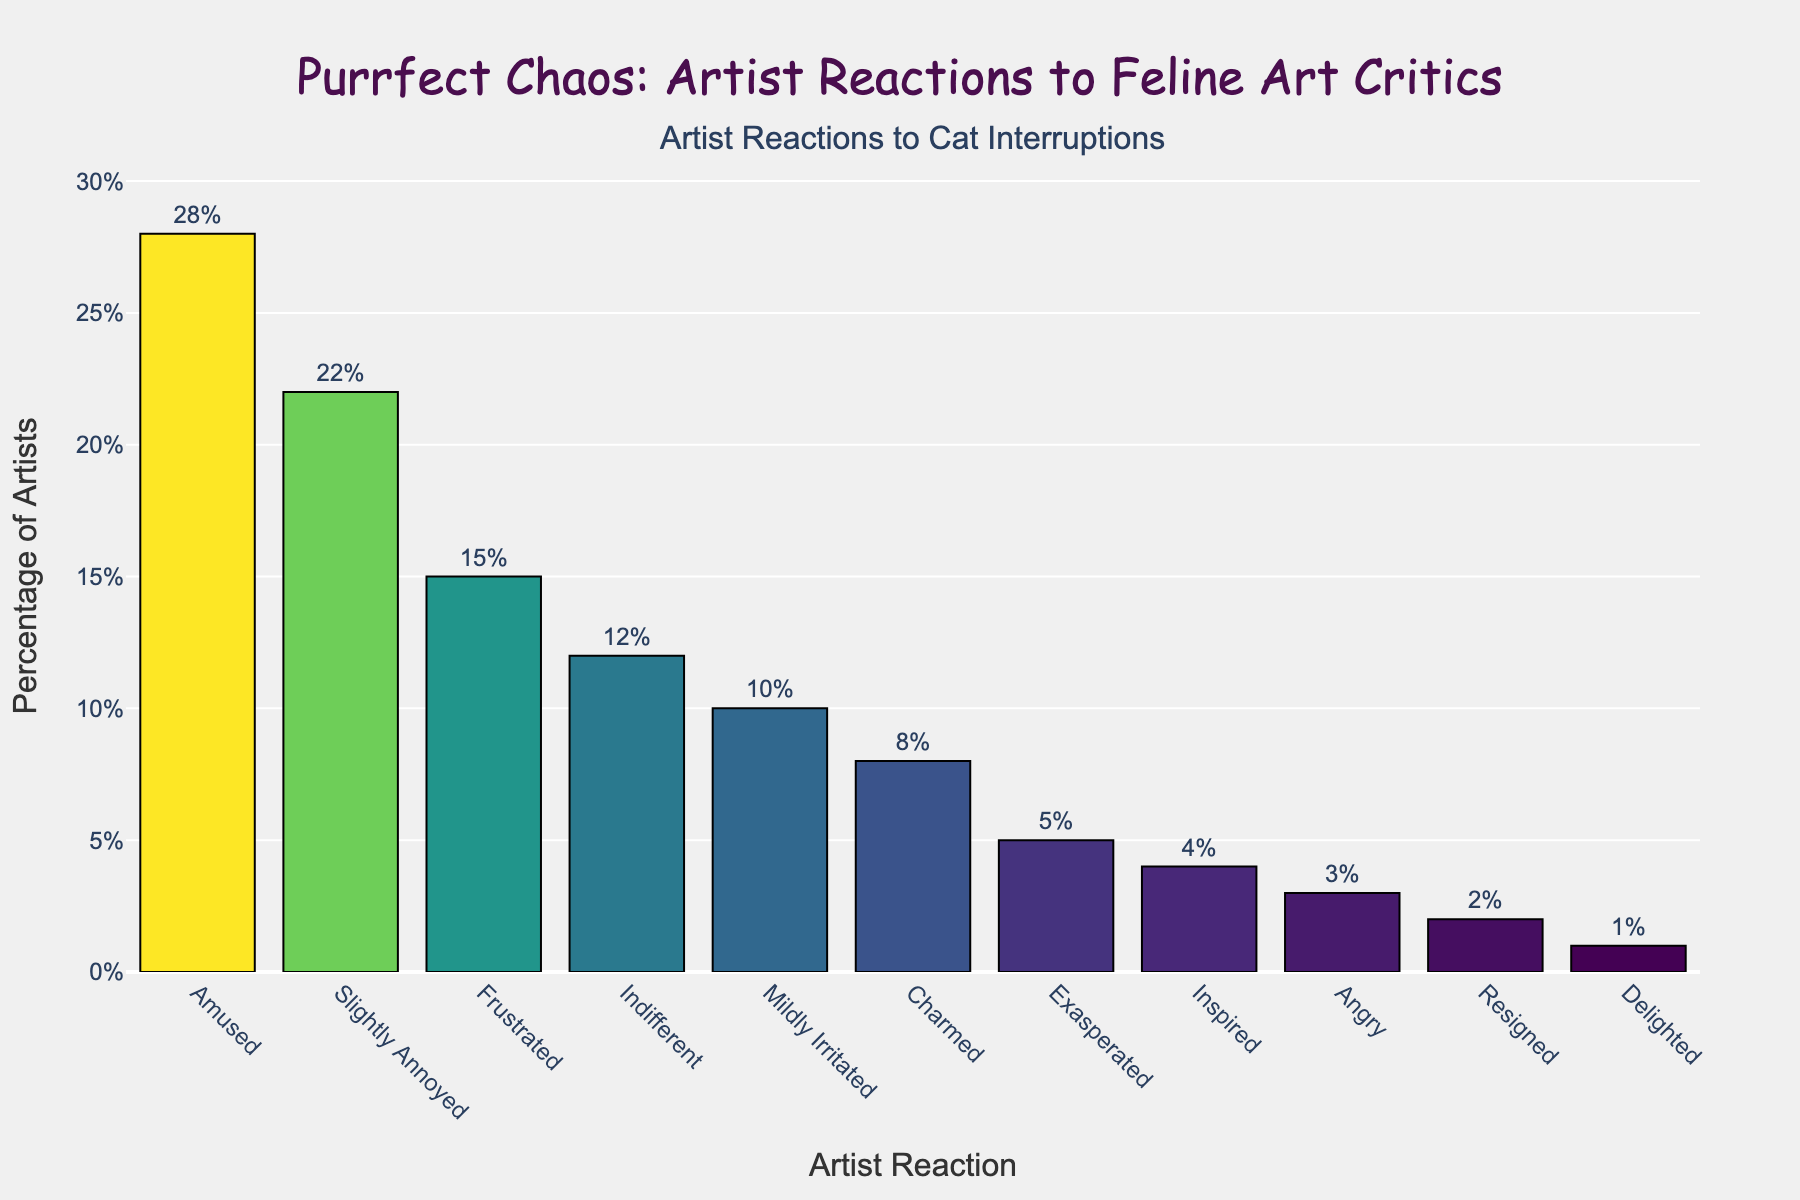Which reaction category has the highest percentage of artists? By looking at the bar heights, the tallest bar represents the highest percentage. The "Amused" category has the highest percentage of 28%.
Answer: Amused How many percentage points more are artists "Amused" than "Frustrated"? Compare the percentages of the two categories. "Amused" is 28% and "Frustrated" is 15%. Subtract the smaller percentage from the larger one: 28% - 15% = 13%.
Answer: 13% Is "Indifferent" more common than "Annoyed" and by what percentage? Look at the bar heights for "Indifferent" and "Annoyed". "Indifferent" is 12% and "Slightly Annoyed" is 22%. Subtract the smaller percentage from the larger one: 22% - 12% = 10%.
Answer: No, by 10% What is the combined percentage of artists who are "Charmed" and "Inspired" by cat interruptions? Sum the percentages of the "Charmed" (8%) and "Inspired" (4%) categories: 8% + 4% = 12%.
Answer: 12% What proportion of artists have positive reactions (Amused, Charmed, Inspired, Delighted) to cat interruptions? Add the percentages of the positive reaction categories: Amused (28%), Charmed (8%), Inspired (4%), Delighted (1%): 28% + 8% + 4% + 1% = 41%.
Answer: 41% Which reaction is less common, "Angry" or "Resigned", and by how much? Compare the bar heights for "Angry" (3%) and "Resigned" (2%). Subtract the smaller percentage from the larger one: 3% - 2% = 1%.
Answer: Resigned, by 1% Are more artists "Exasperated" or "Delighted" by cat interruptions and by what factor? Look at the bar heights for "Exasperated" (5%) and "Delighted" (1%). Divide the larger percentage by the smaller one: 5% / 1% = 5.
Answer: More "Exasperated" by a factor of 5 Compare the percentage of artists who are "Slightly Annoyed" and those who are "Mildly Irritated". Which is higher and by how much? "Slightly Annoyed" is 22% and "Mildly Irritated" is 10%. Subtract the smaller percentage from the larger one: 22% - 10% = 12%.
Answer: Slightly Annoyed, by 12% What is the average percentage of artists who are "Amused," "Charmed," "Inspired," and "Delighted"? Calculate the average of the given categories: (28% + 8% + 4% + 1%) / 4 = 41% / 4 = 10.25%.
Answer: 10.25% Which reaction categories have a percentage higher than the "Mildly Irritated" category? "Mildly Irritated" is 10%. Check all percentages greater than 10%: Amused (28%), Slightly Annoyed (22%), Frustrated (15%), Indifferent (12%).
Answer: Amused, Slightly Annoyed, Frustrated, Indifferent 